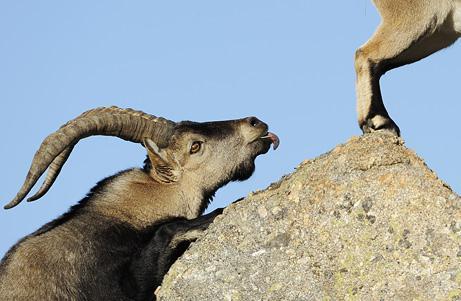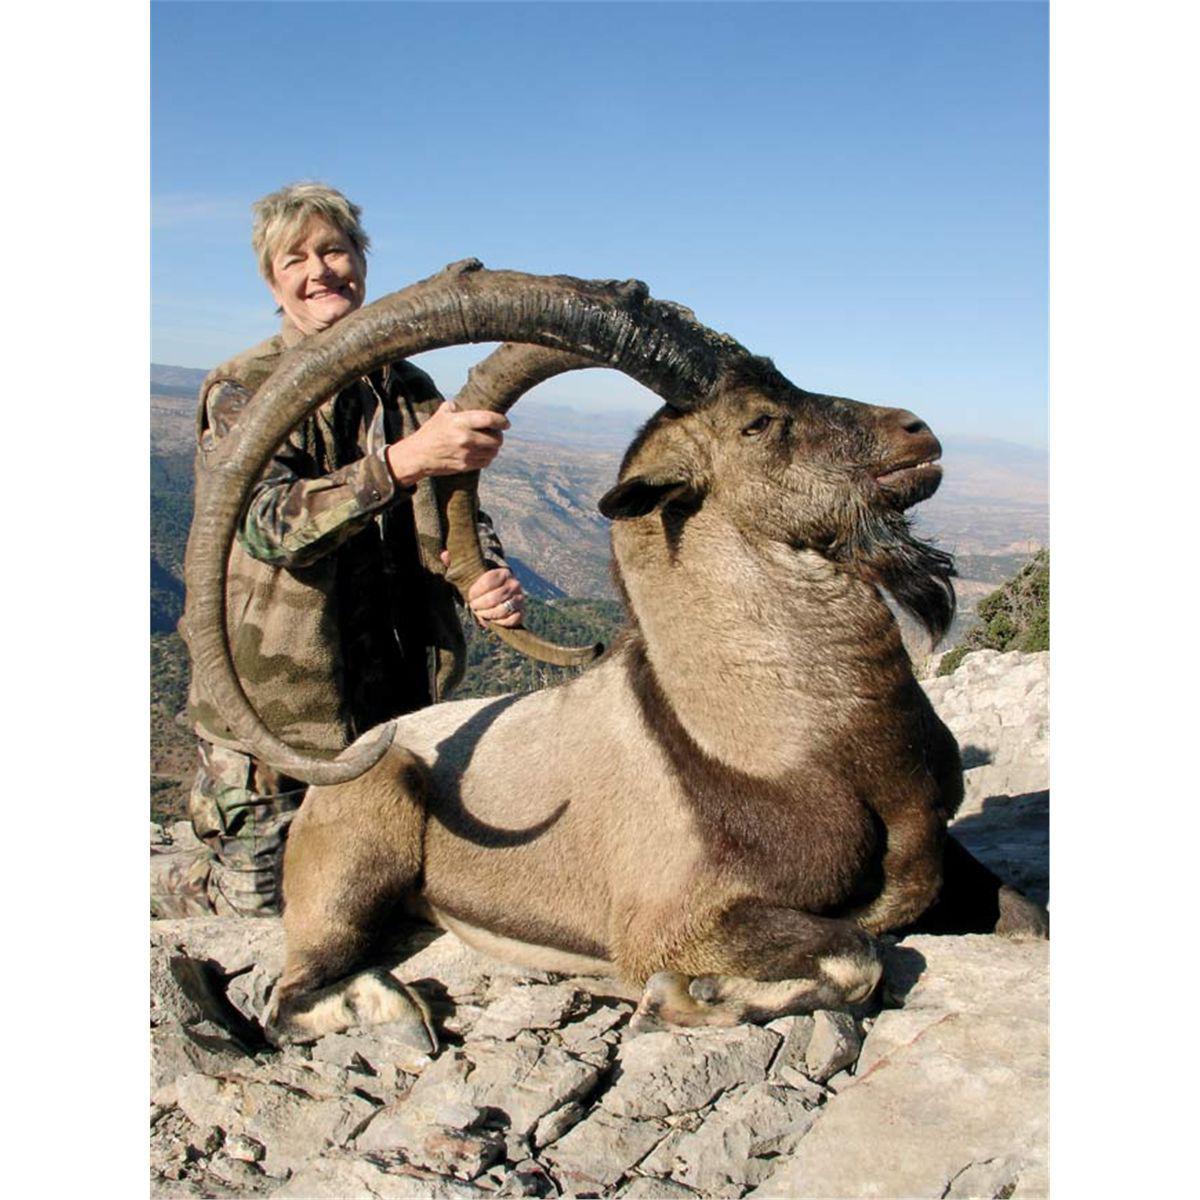The first image is the image on the left, the second image is the image on the right. Assess this claim about the two images: "In one of the images of each pair two of the animals are looking at each other.". Correct or not? Answer yes or no. No. The first image is the image on the left, the second image is the image on the right. Assess this claim about the two images: "In one image the tail of the mountain goat is visible.". Correct or not? Answer yes or no. No. 